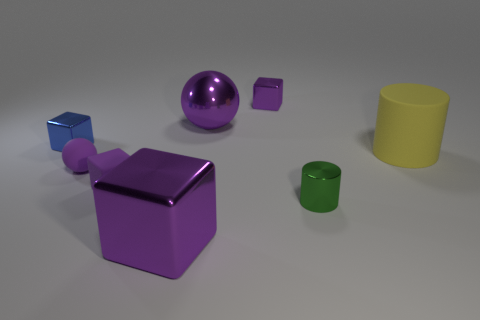What size is the purple ball that is made of the same material as the yellow cylinder?
Keep it short and to the point. Small. The big purple shiny thing behind the tiny block in front of the yellow cylinder is what shape?
Make the answer very short. Sphere. How many yellow objects are shiny balls or balls?
Your answer should be very brief. 0. Is there a small purple shiny thing to the left of the big purple thing in front of the big purple object behind the large metal cube?
Your answer should be compact. No. What is the shape of the rubber object that is the same color as the small matte sphere?
Your response must be concise. Cube. How many big objects are either blue objects or blue rubber cylinders?
Offer a terse response. 0. Do the rubber thing right of the large metallic cube and the small purple shiny object have the same shape?
Give a very brief answer. No. Is the number of red balls less than the number of small blue metallic objects?
Offer a very short reply. Yes. Are there any other things that have the same color as the rubber cylinder?
Make the answer very short. No. What is the shape of the metallic object left of the big purple metal cube?
Offer a very short reply. Cube. 